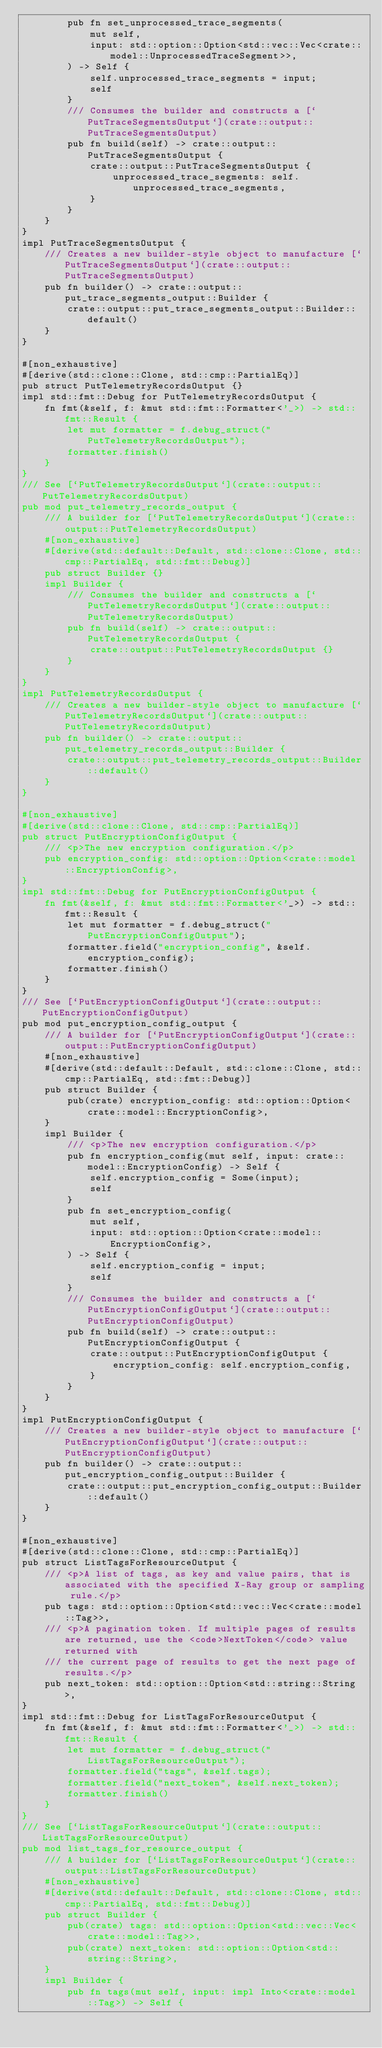<code> <loc_0><loc_0><loc_500><loc_500><_Rust_>        pub fn set_unprocessed_trace_segments(
            mut self,
            input: std::option::Option<std::vec::Vec<crate::model::UnprocessedTraceSegment>>,
        ) -> Self {
            self.unprocessed_trace_segments = input;
            self
        }
        /// Consumes the builder and constructs a [`PutTraceSegmentsOutput`](crate::output::PutTraceSegmentsOutput)
        pub fn build(self) -> crate::output::PutTraceSegmentsOutput {
            crate::output::PutTraceSegmentsOutput {
                unprocessed_trace_segments: self.unprocessed_trace_segments,
            }
        }
    }
}
impl PutTraceSegmentsOutput {
    /// Creates a new builder-style object to manufacture [`PutTraceSegmentsOutput`](crate::output::PutTraceSegmentsOutput)
    pub fn builder() -> crate::output::put_trace_segments_output::Builder {
        crate::output::put_trace_segments_output::Builder::default()
    }
}

#[non_exhaustive]
#[derive(std::clone::Clone, std::cmp::PartialEq)]
pub struct PutTelemetryRecordsOutput {}
impl std::fmt::Debug for PutTelemetryRecordsOutput {
    fn fmt(&self, f: &mut std::fmt::Formatter<'_>) -> std::fmt::Result {
        let mut formatter = f.debug_struct("PutTelemetryRecordsOutput");
        formatter.finish()
    }
}
/// See [`PutTelemetryRecordsOutput`](crate::output::PutTelemetryRecordsOutput)
pub mod put_telemetry_records_output {
    /// A builder for [`PutTelemetryRecordsOutput`](crate::output::PutTelemetryRecordsOutput)
    #[non_exhaustive]
    #[derive(std::default::Default, std::clone::Clone, std::cmp::PartialEq, std::fmt::Debug)]
    pub struct Builder {}
    impl Builder {
        /// Consumes the builder and constructs a [`PutTelemetryRecordsOutput`](crate::output::PutTelemetryRecordsOutput)
        pub fn build(self) -> crate::output::PutTelemetryRecordsOutput {
            crate::output::PutTelemetryRecordsOutput {}
        }
    }
}
impl PutTelemetryRecordsOutput {
    /// Creates a new builder-style object to manufacture [`PutTelemetryRecordsOutput`](crate::output::PutTelemetryRecordsOutput)
    pub fn builder() -> crate::output::put_telemetry_records_output::Builder {
        crate::output::put_telemetry_records_output::Builder::default()
    }
}

#[non_exhaustive]
#[derive(std::clone::Clone, std::cmp::PartialEq)]
pub struct PutEncryptionConfigOutput {
    /// <p>The new encryption configuration.</p>
    pub encryption_config: std::option::Option<crate::model::EncryptionConfig>,
}
impl std::fmt::Debug for PutEncryptionConfigOutput {
    fn fmt(&self, f: &mut std::fmt::Formatter<'_>) -> std::fmt::Result {
        let mut formatter = f.debug_struct("PutEncryptionConfigOutput");
        formatter.field("encryption_config", &self.encryption_config);
        formatter.finish()
    }
}
/// See [`PutEncryptionConfigOutput`](crate::output::PutEncryptionConfigOutput)
pub mod put_encryption_config_output {
    /// A builder for [`PutEncryptionConfigOutput`](crate::output::PutEncryptionConfigOutput)
    #[non_exhaustive]
    #[derive(std::default::Default, std::clone::Clone, std::cmp::PartialEq, std::fmt::Debug)]
    pub struct Builder {
        pub(crate) encryption_config: std::option::Option<crate::model::EncryptionConfig>,
    }
    impl Builder {
        /// <p>The new encryption configuration.</p>
        pub fn encryption_config(mut self, input: crate::model::EncryptionConfig) -> Self {
            self.encryption_config = Some(input);
            self
        }
        pub fn set_encryption_config(
            mut self,
            input: std::option::Option<crate::model::EncryptionConfig>,
        ) -> Self {
            self.encryption_config = input;
            self
        }
        /// Consumes the builder and constructs a [`PutEncryptionConfigOutput`](crate::output::PutEncryptionConfigOutput)
        pub fn build(self) -> crate::output::PutEncryptionConfigOutput {
            crate::output::PutEncryptionConfigOutput {
                encryption_config: self.encryption_config,
            }
        }
    }
}
impl PutEncryptionConfigOutput {
    /// Creates a new builder-style object to manufacture [`PutEncryptionConfigOutput`](crate::output::PutEncryptionConfigOutput)
    pub fn builder() -> crate::output::put_encryption_config_output::Builder {
        crate::output::put_encryption_config_output::Builder::default()
    }
}

#[non_exhaustive]
#[derive(std::clone::Clone, std::cmp::PartialEq)]
pub struct ListTagsForResourceOutput {
    /// <p>A list of tags, as key and value pairs, that is associated with the specified X-Ray group or sampling rule.</p>
    pub tags: std::option::Option<std::vec::Vec<crate::model::Tag>>,
    /// <p>A pagination token. If multiple pages of results are returned, use the <code>NextToken</code> value returned with
    /// the current page of results to get the next page of results.</p>
    pub next_token: std::option::Option<std::string::String>,
}
impl std::fmt::Debug for ListTagsForResourceOutput {
    fn fmt(&self, f: &mut std::fmt::Formatter<'_>) -> std::fmt::Result {
        let mut formatter = f.debug_struct("ListTagsForResourceOutput");
        formatter.field("tags", &self.tags);
        formatter.field("next_token", &self.next_token);
        formatter.finish()
    }
}
/// See [`ListTagsForResourceOutput`](crate::output::ListTagsForResourceOutput)
pub mod list_tags_for_resource_output {
    /// A builder for [`ListTagsForResourceOutput`](crate::output::ListTagsForResourceOutput)
    #[non_exhaustive]
    #[derive(std::default::Default, std::clone::Clone, std::cmp::PartialEq, std::fmt::Debug)]
    pub struct Builder {
        pub(crate) tags: std::option::Option<std::vec::Vec<crate::model::Tag>>,
        pub(crate) next_token: std::option::Option<std::string::String>,
    }
    impl Builder {
        pub fn tags(mut self, input: impl Into<crate::model::Tag>) -> Self {</code> 